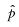<formula> <loc_0><loc_0><loc_500><loc_500>\hat { p }</formula> 